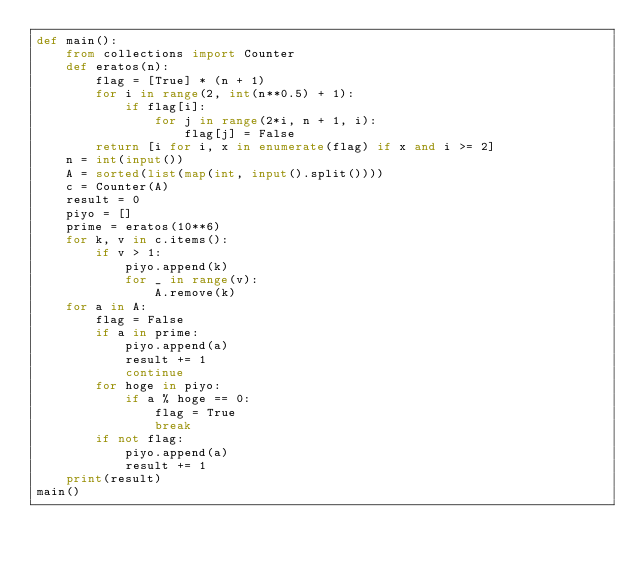<code> <loc_0><loc_0><loc_500><loc_500><_Python_>def main():
    from collections import Counter
    def eratos(n):
        flag = [True] * (n + 1)
        for i in range(2, int(n**0.5) + 1):
            if flag[i]:
                for j in range(2*i, n + 1, i):
                    flag[j] = False
        return [i for i, x in enumerate(flag) if x and i >= 2]
    n = int(input())
    A = sorted(list(map(int, input().split())))
    c = Counter(A)
    result = 0
    piyo = []
    prime = eratos(10**6)
    for k, v in c.items():
        if v > 1:
            piyo.append(k)
            for _ in range(v):
                A.remove(k)
    for a in A:
        flag = False
        if a in prime:
            piyo.append(a)
            result += 1
            continue
        for hoge in piyo:
            if a % hoge == 0:
                flag = True
                break
        if not flag:
            piyo.append(a)
            result += 1
    print(result)
main()</code> 